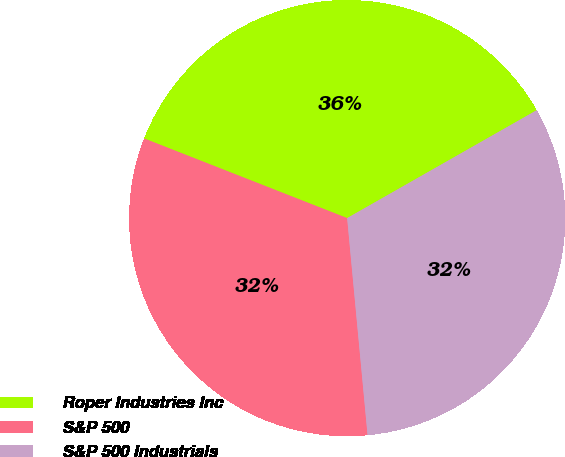<chart> <loc_0><loc_0><loc_500><loc_500><pie_chart><fcel>Roper Industries Inc<fcel>S&P 500<fcel>S&P 500 Industrials<nl><fcel>35.81%<fcel>32.44%<fcel>31.74%<nl></chart> 